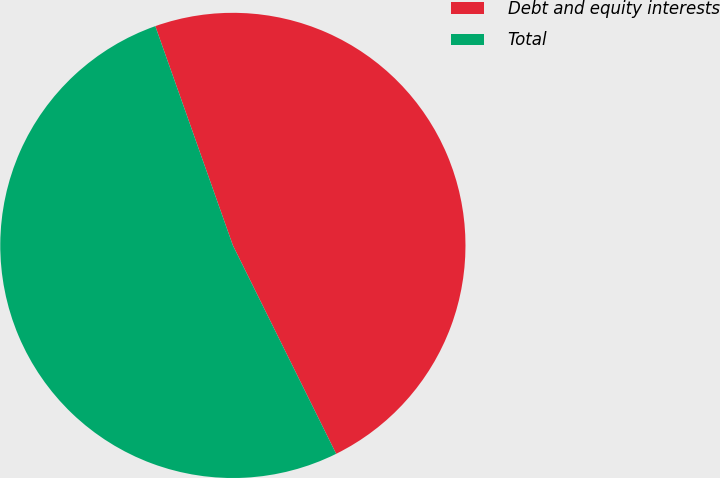Convert chart to OTSL. <chart><loc_0><loc_0><loc_500><loc_500><pie_chart><fcel>Debt and equity interests<fcel>Total<nl><fcel>48.09%<fcel>51.91%<nl></chart> 